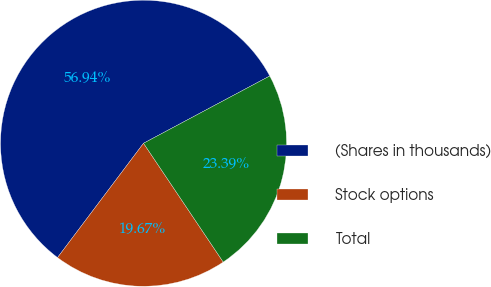Convert chart. <chart><loc_0><loc_0><loc_500><loc_500><pie_chart><fcel>(Shares in thousands)<fcel>Stock options<fcel>Total<nl><fcel>56.94%<fcel>19.67%<fcel>23.39%<nl></chart> 